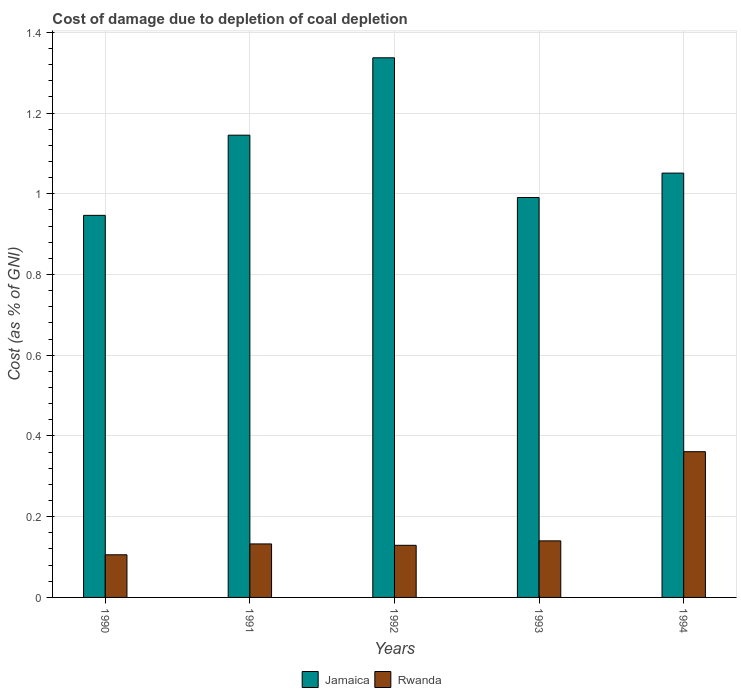Are the number of bars per tick equal to the number of legend labels?
Make the answer very short. Yes. How many bars are there on the 4th tick from the left?
Make the answer very short. 2. How many bars are there on the 2nd tick from the right?
Keep it short and to the point. 2. What is the cost of damage caused due to coal depletion in Rwanda in 1993?
Ensure brevity in your answer.  0.14. Across all years, what is the maximum cost of damage caused due to coal depletion in Jamaica?
Your answer should be very brief. 1.34. Across all years, what is the minimum cost of damage caused due to coal depletion in Rwanda?
Your answer should be compact. 0.11. What is the total cost of damage caused due to coal depletion in Jamaica in the graph?
Provide a short and direct response. 5.47. What is the difference between the cost of damage caused due to coal depletion in Jamaica in 1991 and that in 1992?
Your response must be concise. -0.19. What is the difference between the cost of damage caused due to coal depletion in Rwanda in 1993 and the cost of damage caused due to coal depletion in Jamaica in 1991?
Your answer should be very brief. -1.01. What is the average cost of damage caused due to coal depletion in Jamaica per year?
Ensure brevity in your answer.  1.09. In the year 1994, what is the difference between the cost of damage caused due to coal depletion in Rwanda and cost of damage caused due to coal depletion in Jamaica?
Provide a succinct answer. -0.69. What is the ratio of the cost of damage caused due to coal depletion in Jamaica in 1991 to that in 1993?
Your answer should be compact. 1.16. Is the cost of damage caused due to coal depletion in Rwanda in 1992 less than that in 1993?
Offer a terse response. Yes. What is the difference between the highest and the second highest cost of damage caused due to coal depletion in Jamaica?
Make the answer very short. 0.19. What is the difference between the highest and the lowest cost of damage caused due to coal depletion in Jamaica?
Provide a succinct answer. 0.39. What does the 1st bar from the left in 1992 represents?
Keep it short and to the point. Jamaica. What does the 1st bar from the right in 1990 represents?
Offer a terse response. Rwanda. How many bars are there?
Give a very brief answer. 10. How many years are there in the graph?
Provide a succinct answer. 5. What is the difference between two consecutive major ticks on the Y-axis?
Provide a short and direct response. 0.2. How many legend labels are there?
Provide a succinct answer. 2. How are the legend labels stacked?
Make the answer very short. Horizontal. What is the title of the graph?
Your answer should be very brief. Cost of damage due to depletion of coal depletion. Does "Niger" appear as one of the legend labels in the graph?
Provide a succinct answer. No. What is the label or title of the X-axis?
Your answer should be compact. Years. What is the label or title of the Y-axis?
Provide a short and direct response. Cost (as % of GNI). What is the Cost (as % of GNI) in Jamaica in 1990?
Make the answer very short. 0.95. What is the Cost (as % of GNI) in Rwanda in 1990?
Give a very brief answer. 0.11. What is the Cost (as % of GNI) in Jamaica in 1991?
Your response must be concise. 1.15. What is the Cost (as % of GNI) of Rwanda in 1991?
Your response must be concise. 0.13. What is the Cost (as % of GNI) in Jamaica in 1992?
Offer a terse response. 1.34. What is the Cost (as % of GNI) of Rwanda in 1992?
Your answer should be compact. 0.13. What is the Cost (as % of GNI) in Jamaica in 1993?
Give a very brief answer. 0.99. What is the Cost (as % of GNI) in Rwanda in 1993?
Your response must be concise. 0.14. What is the Cost (as % of GNI) of Jamaica in 1994?
Make the answer very short. 1.05. What is the Cost (as % of GNI) in Rwanda in 1994?
Your response must be concise. 0.36. Across all years, what is the maximum Cost (as % of GNI) in Jamaica?
Make the answer very short. 1.34. Across all years, what is the maximum Cost (as % of GNI) of Rwanda?
Make the answer very short. 0.36. Across all years, what is the minimum Cost (as % of GNI) in Jamaica?
Your answer should be very brief. 0.95. Across all years, what is the minimum Cost (as % of GNI) in Rwanda?
Offer a terse response. 0.11. What is the total Cost (as % of GNI) in Jamaica in the graph?
Offer a very short reply. 5.47. What is the total Cost (as % of GNI) of Rwanda in the graph?
Your answer should be very brief. 0.87. What is the difference between the Cost (as % of GNI) in Jamaica in 1990 and that in 1991?
Give a very brief answer. -0.2. What is the difference between the Cost (as % of GNI) in Rwanda in 1990 and that in 1991?
Provide a short and direct response. -0.03. What is the difference between the Cost (as % of GNI) in Jamaica in 1990 and that in 1992?
Your response must be concise. -0.39. What is the difference between the Cost (as % of GNI) in Rwanda in 1990 and that in 1992?
Your response must be concise. -0.02. What is the difference between the Cost (as % of GNI) in Jamaica in 1990 and that in 1993?
Offer a very short reply. -0.04. What is the difference between the Cost (as % of GNI) of Rwanda in 1990 and that in 1993?
Offer a terse response. -0.03. What is the difference between the Cost (as % of GNI) of Jamaica in 1990 and that in 1994?
Make the answer very short. -0.1. What is the difference between the Cost (as % of GNI) of Rwanda in 1990 and that in 1994?
Your answer should be compact. -0.26. What is the difference between the Cost (as % of GNI) in Jamaica in 1991 and that in 1992?
Your response must be concise. -0.19. What is the difference between the Cost (as % of GNI) of Rwanda in 1991 and that in 1992?
Offer a very short reply. 0. What is the difference between the Cost (as % of GNI) in Jamaica in 1991 and that in 1993?
Provide a succinct answer. 0.15. What is the difference between the Cost (as % of GNI) in Rwanda in 1991 and that in 1993?
Provide a succinct answer. -0.01. What is the difference between the Cost (as % of GNI) in Jamaica in 1991 and that in 1994?
Your answer should be very brief. 0.09. What is the difference between the Cost (as % of GNI) in Rwanda in 1991 and that in 1994?
Offer a very short reply. -0.23. What is the difference between the Cost (as % of GNI) of Jamaica in 1992 and that in 1993?
Your response must be concise. 0.35. What is the difference between the Cost (as % of GNI) in Rwanda in 1992 and that in 1993?
Offer a terse response. -0.01. What is the difference between the Cost (as % of GNI) in Jamaica in 1992 and that in 1994?
Your answer should be compact. 0.29. What is the difference between the Cost (as % of GNI) in Rwanda in 1992 and that in 1994?
Offer a very short reply. -0.23. What is the difference between the Cost (as % of GNI) of Jamaica in 1993 and that in 1994?
Offer a terse response. -0.06. What is the difference between the Cost (as % of GNI) in Rwanda in 1993 and that in 1994?
Give a very brief answer. -0.22. What is the difference between the Cost (as % of GNI) of Jamaica in 1990 and the Cost (as % of GNI) of Rwanda in 1991?
Your response must be concise. 0.81. What is the difference between the Cost (as % of GNI) of Jamaica in 1990 and the Cost (as % of GNI) of Rwanda in 1992?
Give a very brief answer. 0.82. What is the difference between the Cost (as % of GNI) in Jamaica in 1990 and the Cost (as % of GNI) in Rwanda in 1993?
Provide a succinct answer. 0.81. What is the difference between the Cost (as % of GNI) in Jamaica in 1990 and the Cost (as % of GNI) in Rwanda in 1994?
Ensure brevity in your answer.  0.59. What is the difference between the Cost (as % of GNI) in Jamaica in 1991 and the Cost (as % of GNI) in Rwanda in 1992?
Your response must be concise. 1.02. What is the difference between the Cost (as % of GNI) in Jamaica in 1991 and the Cost (as % of GNI) in Rwanda in 1993?
Ensure brevity in your answer.  1.01. What is the difference between the Cost (as % of GNI) in Jamaica in 1991 and the Cost (as % of GNI) in Rwanda in 1994?
Offer a very short reply. 0.78. What is the difference between the Cost (as % of GNI) in Jamaica in 1992 and the Cost (as % of GNI) in Rwanda in 1993?
Your answer should be very brief. 1.2. What is the difference between the Cost (as % of GNI) of Jamaica in 1992 and the Cost (as % of GNI) of Rwanda in 1994?
Your answer should be very brief. 0.98. What is the difference between the Cost (as % of GNI) of Jamaica in 1993 and the Cost (as % of GNI) of Rwanda in 1994?
Ensure brevity in your answer.  0.63. What is the average Cost (as % of GNI) of Jamaica per year?
Give a very brief answer. 1.09. What is the average Cost (as % of GNI) of Rwanda per year?
Provide a short and direct response. 0.17. In the year 1990, what is the difference between the Cost (as % of GNI) of Jamaica and Cost (as % of GNI) of Rwanda?
Your answer should be compact. 0.84. In the year 1991, what is the difference between the Cost (as % of GNI) in Jamaica and Cost (as % of GNI) in Rwanda?
Ensure brevity in your answer.  1.01. In the year 1992, what is the difference between the Cost (as % of GNI) of Jamaica and Cost (as % of GNI) of Rwanda?
Your answer should be very brief. 1.21. In the year 1993, what is the difference between the Cost (as % of GNI) in Jamaica and Cost (as % of GNI) in Rwanda?
Provide a succinct answer. 0.85. In the year 1994, what is the difference between the Cost (as % of GNI) of Jamaica and Cost (as % of GNI) of Rwanda?
Make the answer very short. 0.69. What is the ratio of the Cost (as % of GNI) in Jamaica in 1990 to that in 1991?
Your answer should be compact. 0.83. What is the ratio of the Cost (as % of GNI) in Rwanda in 1990 to that in 1991?
Your answer should be compact. 0.8. What is the ratio of the Cost (as % of GNI) in Jamaica in 1990 to that in 1992?
Make the answer very short. 0.71. What is the ratio of the Cost (as % of GNI) in Rwanda in 1990 to that in 1992?
Offer a very short reply. 0.82. What is the ratio of the Cost (as % of GNI) in Jamaica in 1990 to that in 1993?
Give a very brief answer. 0.96. What is the ratio of the Cost (as % of GNI) in Rwanda in 1990 to that in 1993?
Keep it short and to the point. 0.75. What is the ratio of the Cost (as % of GNI) of Jamaica in 1990 to that in 1994?
Provide a succinct answer. 0.9. What is the ratio of the Cost (as % of GNI) in Rwanda in 1990 to that in 1994?
Ensure brevity in your answer.  0.29. What is the ratio of the Cost (as % of GNI) of Jamaica in 1991 to that in 1992?
Provide a succinct answer. 0.86. What is the ratio of the Cost (as % of GNI) of Rwanda in 1991 to that in 1992?
Ensure brevity in your answer.  1.03. What is the ratio of the Cost (as % of GNI) of Jamaica in 1991 to that in 1993?
Your answer should be compact. 1.16. What is the ratio of the Cost (as % of GNI) of Rwanda in 1991 to that in 1993?
Give a very brief answer. 0.95. What is the ratio of the Cost (as % of GNI) of Jamaica in 1991 to that in 1994?
Provide a short and direct response. 1.09. What is the ratio of the Cost (as % of GNI) in Rwanda in 1991 to that in 1994?
Your answer should be compact. 0.37. What is the ratio of the Cost (as % of GNI) of Jamaica in 1992 to that in 1993?
Provide a succinct answer. 1.35. What is the ratio of the Cost (as % of GNI) of Rwanda in 1992 to that in 1993?
Provide a succinct answer. 0.92. What is the ratio of the Cost (as % of GNI) of Jamaica in 1992 to that in 1994?
Offer a very short reply. 1.27. What is the ratio of the Cost (as % of GNI) of Rwanda in 1992 to that in 1994?
Your response must be concise. 0.36. What is the ratio of the Cost (as % of GNI) in Jamaica in 1993 to that in 1994?
Your answer should be very brief. 0.94. What is the ratio of the Cost (as % of GNI) of Rwanda in 1993 to that in 1994?
Ensure brevity in your answer.  0.39. What is the difference between the highest and the second highest Cost (as % of GNI) in Jamaica?
Your answer should be very brief. 0.19. What is the difference between the highest and the second highest Cost (as % of GNI) of Rwanda?
Your answer should be compact. 0.22. What is the difference between the highest and the lowest Cost (as % of GNI) of Jamaica?
Give a very brief answer. 0.39. What is the difference between the highest and the lowest Cost (as % of GNI) of Rwanda?
Your response must be concise. 0.26. 